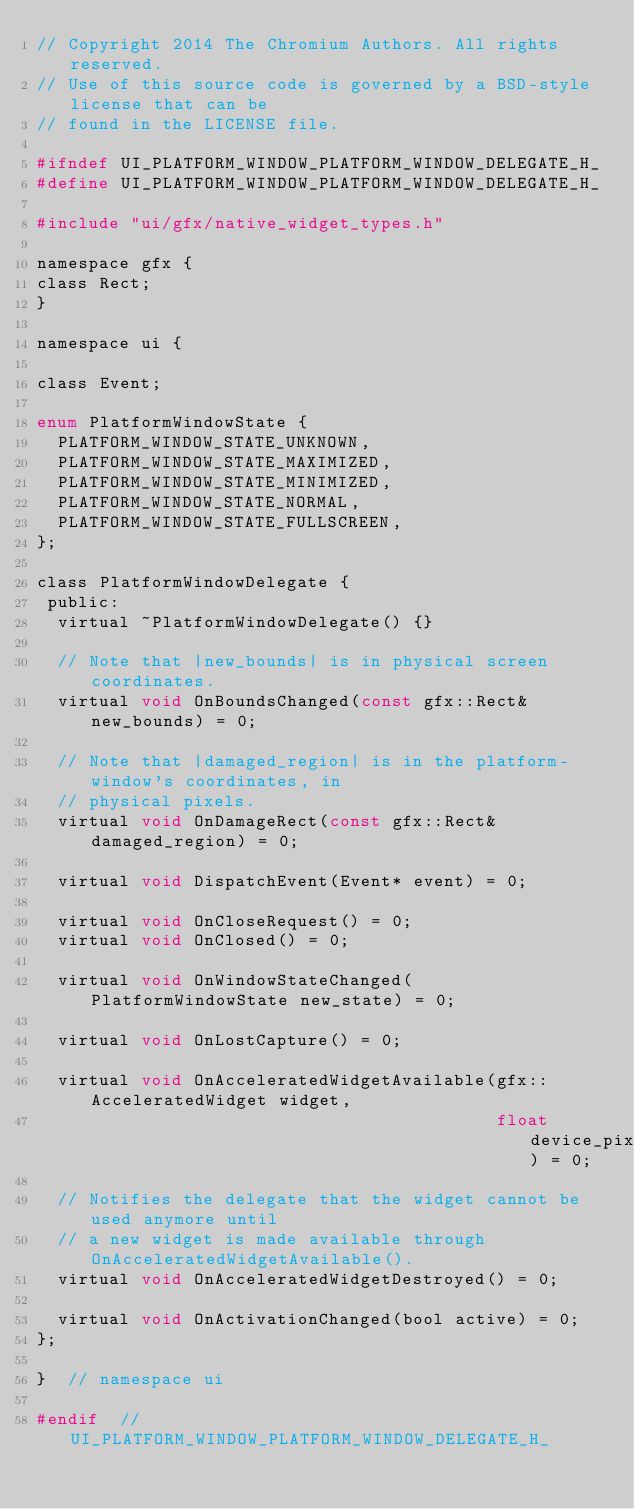Convert code to text. <code><loc_0><loc_0><loc_500><loc_500><_C_>// Copyright 2014 The Chromium Authors. All rights reserved.
// Use of this source code is governed by a BSD-style license that can be
// found in the LICENSE file.

#ifndef UI_PLATFORM_WINDOW_PLATFORM_WINDOW_DELEGATE_H_
#define UI_PLATFORM_WINDOW_PLATFORM_WINDOW_DELEGATE_H_

#include "ui/gfx/native_widget_types.h"

namespace gfx {
class Rect;
}

namespace ui {

class Event;

enum PlatformWindowState {
  PLATFORM_WINDOW_STATE_UNKNOWN,
  PLATFORM_WINDOW_STATE_MAXIMIZED,
  PLATFORM_WINDOW_STATE_MINIMIZED,
  PLATFORM_WINDOW_STATE_NORMAL,
  PLATFORM_WINDOW_STATE_FULLSCREEN,
};

class PlatformWindowDelegate {
 public:
  virtual ~PlatformWindowDelegate() {}

  // Note that |new_bounds| is in physical screen coordinates.
  virtual void OnBoundsChanged(const gfx::Rect& new_bounds) = 0;

  // Note that |damaged_region| is in the platform-window's coordinates, in
  // physical pixels.
  virtual void OnDamageRect(const gfx::Rect& damaged_region) = 0;

  virtual void DispatchEvent(Event* event) = 0;

  virtual void OnCloseRequest() = 0;
  virtual void OnClosed() = 0;

  virtual void OnWindowStateChanged(PlatformWindowState new_state) = 0;

  virtual void OnLostCapture() = 0;

  virtual void OnAcceleratedWidgetAvailable(gfx::AcceleratedWidget widget,
                                            float device_pixel_ratio) = 0;

  // Notifies the delegate that the widget cannot be used anymore until
  // a new widget is made available through OnAcceleratedWidgetAvailable().
  virtual void OnAcceleratedWidgetDestroyed() = 0;

  virtual void OnActivationChanged(bool active) = 0;
};

}  // namespace ui

#endif  // UI_PLATFORM_WINDOW_PLATFORM_WINDOW_DELEGATE_H_
</code> 